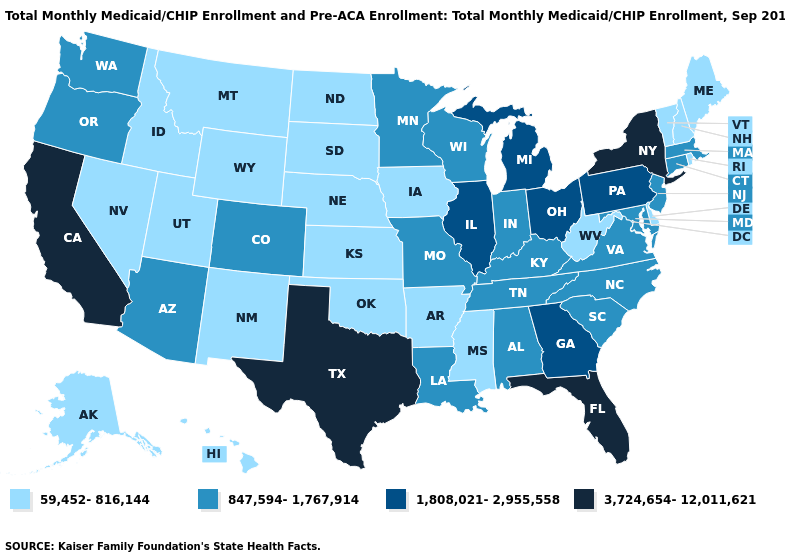Does South Dakota have the lowest value in the MidWest?
Concise answer only. Yes. Among the states that border Illinois , does Missouri have the highest value?
Be succinct. Yes. Does Alaska have a lower value than Idaho?
Quick response, please. No. Does the map have missing data?
Short answer required. No. What is the highest value in states that border Nevada?
Give a very brief answer. 3,724,654-12,011,621. Does the map have missing data?
Answer briefly. No. Does the first symbol in the legend represent the smallest category?
Short answer required. Yes. Name the states that have a value in the range 3,724,654-12,011,621?
Quick response, please. California, Florida, New York, Texas. What is the lowest value in states that border Rhode Island?
Write a very short answer. 847,594-1,767,914. Name the states that have a value in the range 1,808,021-2,955,558?
Write a very short answer. Georgia, Illinois, Michigan, Ohio, Pennsylvania. What is the lowest value in the USA?
Short answer required. 59,452-816,144. Does Texas have the same value as Florida?
Quick response, please. Yes. What is the highest value in the USA?
Answer briefly. 3,724,654-12,011,621. Does Texas have the highest value in the USA?
Short answer required. Yes. Which states have the lowest value in the South?
Write a very short answer. Arkansas, Delaware, Mississippi, Oklahoma, West Virginia. 